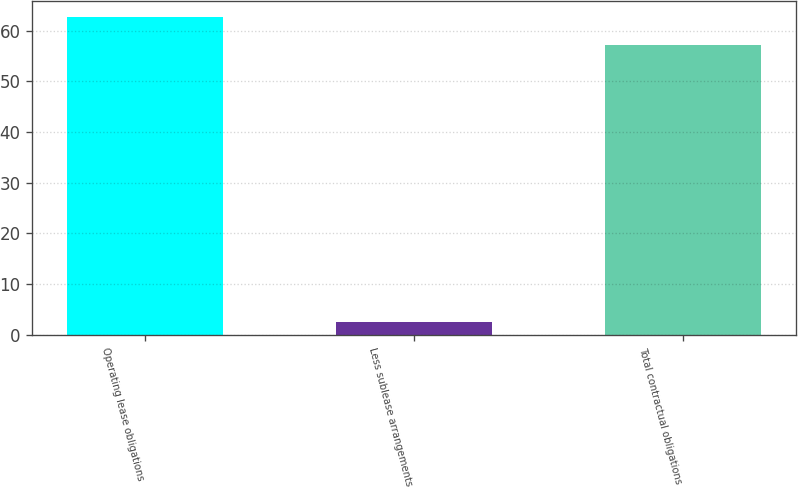<chart> <loc_0><loc_0><loc_500><loc_500><bar_chart><fcel>Operating lease obligations<fcel>Less sublease arrangements<fcel>Total contractual obligations<nl><fcel>62.75<fcel>2.5<fcel>57.1<nl></chart> 